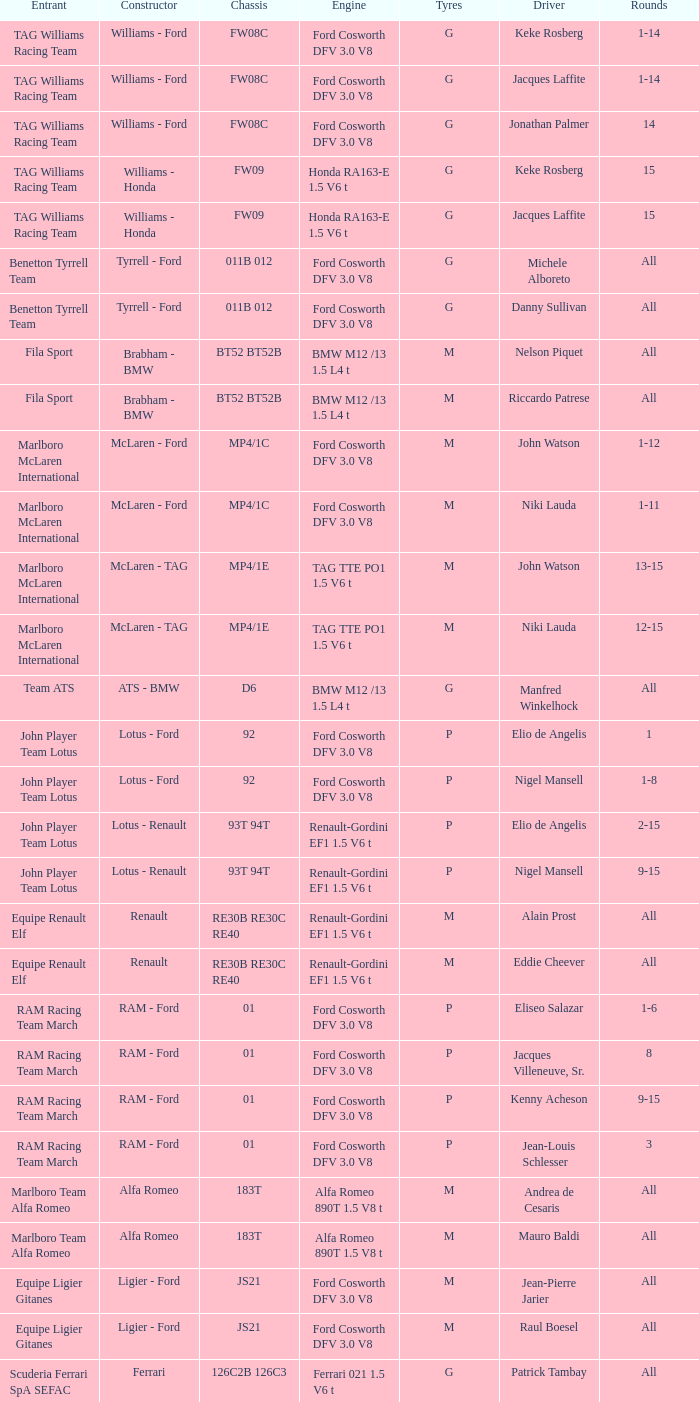Who is the constructor for driver Niki Lauda and a chassis of mp4/1c? McLaren - Ford. 